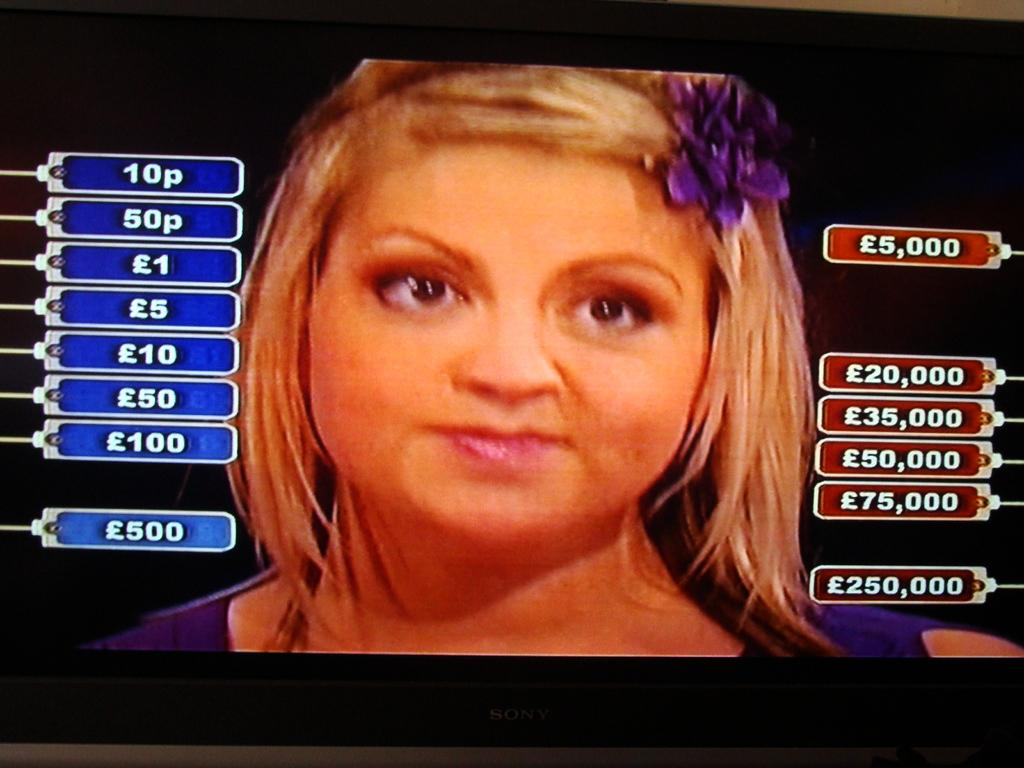Who is the main subject in the image? There is a woman in the center of the image. What can be seen on the left side of the image? There are numbers in boxes on the left side of the image. What is present on the right side of the image? There are numbers in boxes on the right side of the image. What type of device is displaying the image? The image is a television screen. Can you see a group of people enjoying the seashore in the image? There is no seashore or group of people present in the image; it features a woman and numbers in boxes on a television screen. 